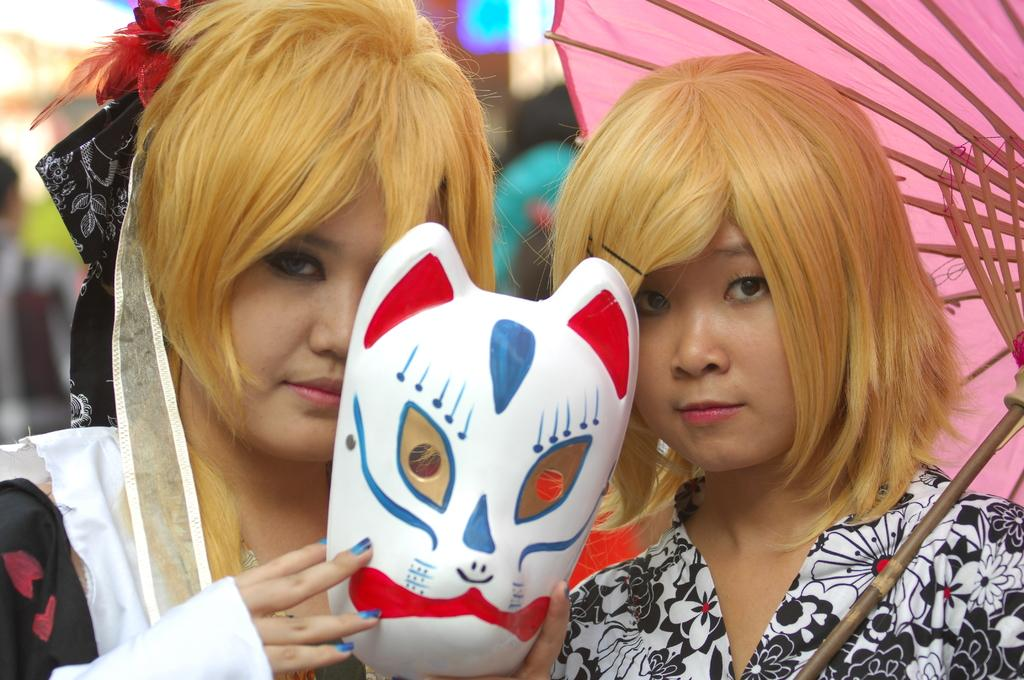What is the woman on the right side of the image holding? The woman on the right side of the image is holding a mask. What is the woman on the left side of the image holding? The woman on the left side of the image is holding an umbrella. Can you describe the background of the image? The background of the image is blurred. How many people are visible in the image? There is at least one person visible on the left side of the image. What type of substance is being dropped by the person on the right side of the image? There is no person on the right side of the image, and no substance is being dropped. What is the profit margin of the mask being held by the woman on the right side of the image? There is no information about the profit margin of the mask in the image. 